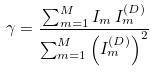<formula> <loc_0><loc_0><loc_500><loc_500>\gamma = \frac { \sum _ { m = 1 } ^ { M } I _ { m } \, I ^ { ( D ) } _ { m } } { \sum _ { m = 1 } ^ { M } \left ( I ^ { ( D ) } _ { m } \right ) ^ { 2 } }</formula> 